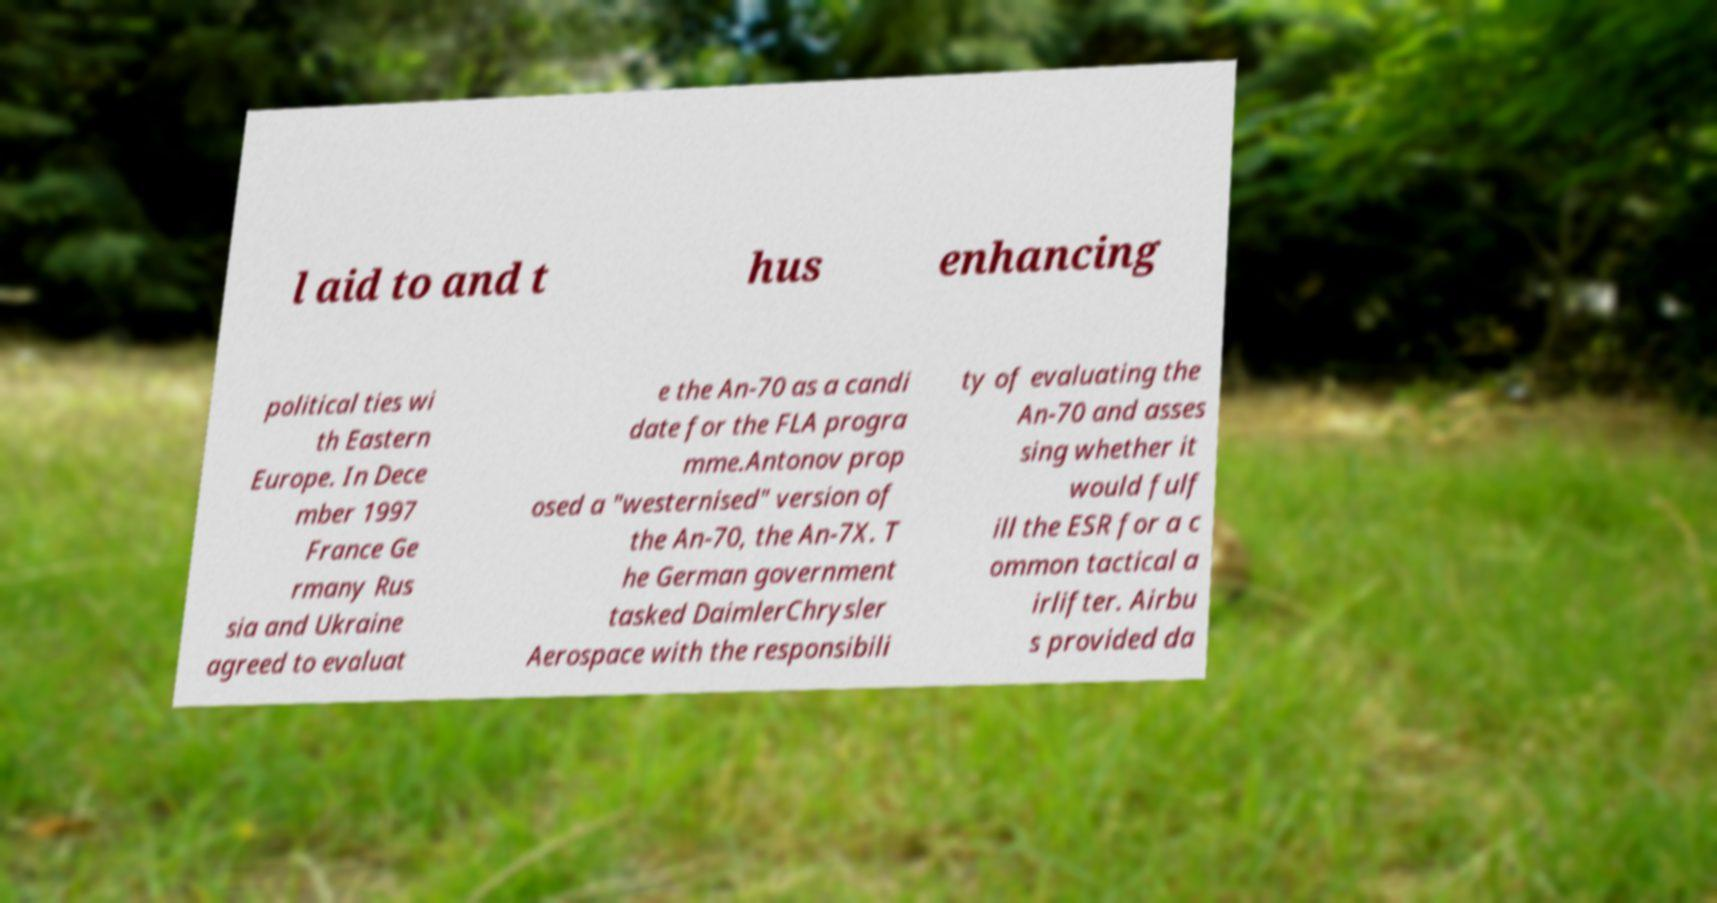There's text embedded in this image that I need extracted. Can you transcribe it verbatim? l aid to and t hus enhancing political ties wi th Eastern Europe. In Dece mber 1997 France Ge rmany Rus sia and Ukraine agreed to evaluat e the An-70 as a candi date for the FLA progra mme.Antonov prop osed a "westernised" version of the An-70, the An-7X. T he German government tasked DaimlerChrysler Aerospace with the responsibili ty of evaluating the An-70 and asses sing whether it would fulf ill the ESR for a c ommon tactical a irlifter. Airbu s provided da 